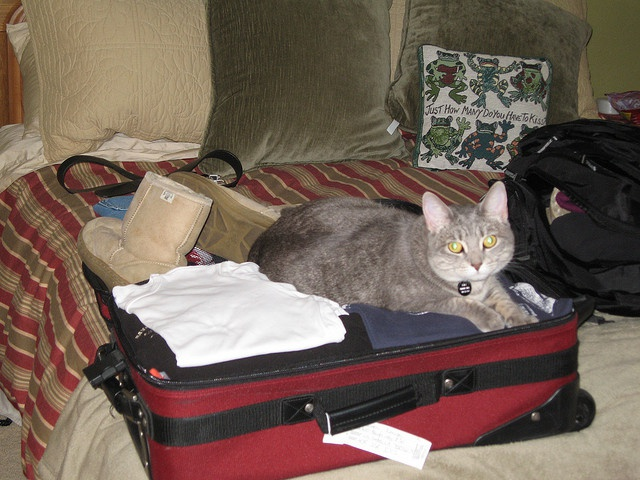Describe the objects in this image and their specific colors. I can see bed in black, gray, tan, and darkgray tones, suitcase in olive, black, brown, and maroon tones, cat in olive, gray, darkgray, and lightgray tones, and backpack in olive, black, gray, and purple tones in this image. 